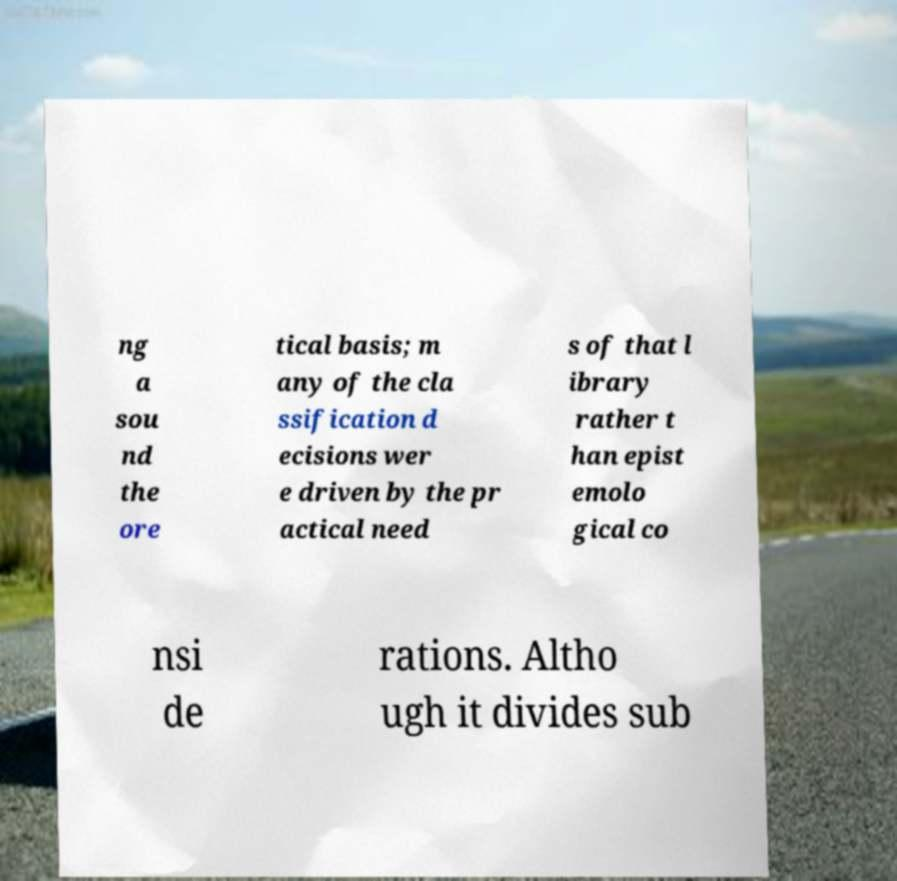Can you read and provide the text displayed in the image?This photo seems to have some interesting text. Can you extract and type it out for me? ng a sou nd the ore tical basis; m any of the cla ssification d ecisions wer e driven by the pr actical need s of that l ibrary rather t han epist emolo gical co nsi de rations. Altho ugh it divides sub 